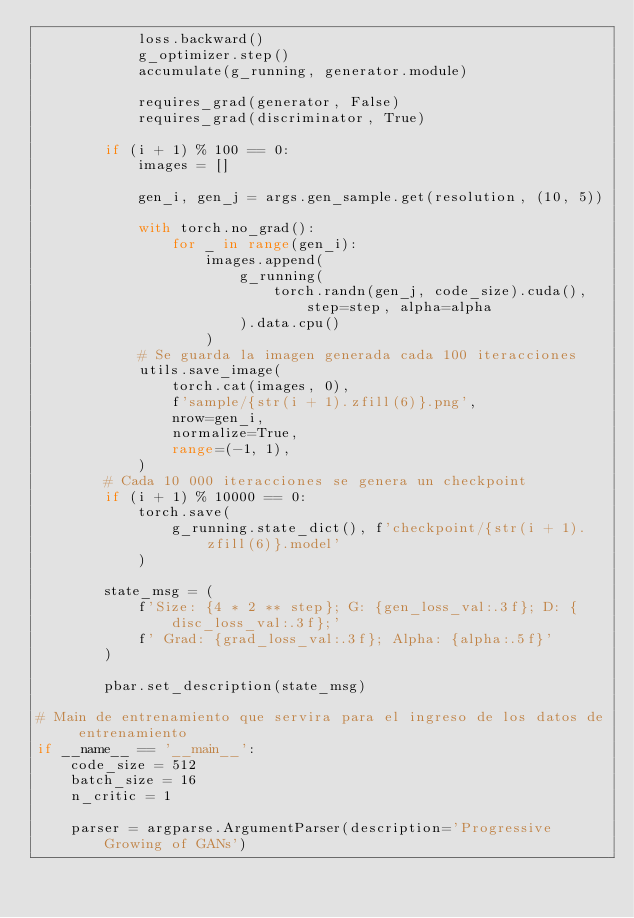Convert code to text. <code><loc_0><loc_0><loc_500><loc_500><_Python_>            loss.backward()
            g_optimizer.step()
            accumulate(g_running, generator.module)

            requires_grad(generator, False)
            requires_grad(discriminator, True)

        if (i + 1) % 100 == 0:
            images = []

            gen_i, gen_j = args.gen_sample.get(resolution, (10, 5))

            with torch.no_grad():
                for _ in range(gen_i):
                    images.append(
                        g_running(
                            torch.randn(gen_j, code_size).cuda(), step=step, alpha=alpha
                        ).data.cpu()
                    )
            # Se guarda la imagen generada cada 100 iteracciones
            utils.save_image(
                torch.cat(images, 0),
                f'sample/{str(i + 1).zfill(6)}.png',
                nrow=gen_i,
                normalize=True,
                range=(-1, 1),
            )
        # Cada 10 000 iteracciones se genera un checkpoint
        if (i + 1) % 10000 == 0:
            torch.save(
                g_running.state_dict(), f'checkpoint/{str(i + 1).zfill(6)}.model'
            )

        state_msg = (
            f'Size: {4 * 2 ** step}; G: {gen_loss_val:.3f}; D: {disc_loss_val:.3f};'
            f' Grad: {grad_loss_val:.3f}; Alpha: {alpha:.5f}'
        )

        pbar.set_description(state_msg)

# Main de entrenamiento que servira para el ingreso de los datos de entrenamiento
if __name__ == '__main__':
    code_size = 512
    batch_size = 16
    n_critic = 1

    parser = argparse.ArgumentParser(description='Progressive Growing of GANs')
</code> 